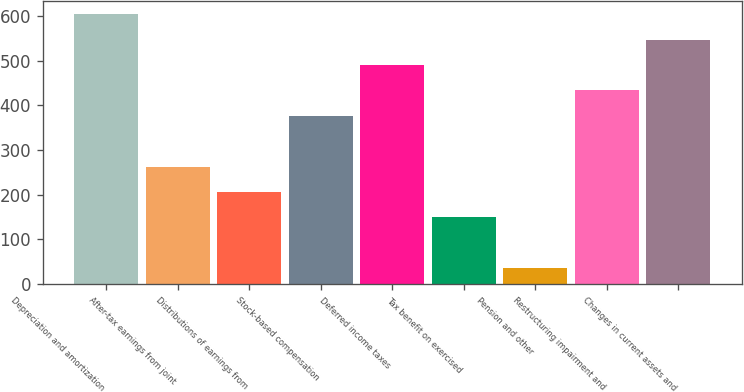Convert chart to OTSL. <chart><loc_0><loc_0><loc_500><loc_500><bar_chart><fcel>Depreciation and amortization<fcel>After-tax earnings from joint<fcel>Distributions of earnings from<fcel>Stock-based compensation<fcel>Deferred income taxes<fcel>Tax benefit on exercised<fcel>Pension and other<fcel>Restructuring impairment and<fcel>Changes in current assets and<nl><fcel>603.6<fcel>262.86<fcel>206.07<fcel>376.44<fcel>490.02<fcel>149.28<fcel>35.7<fcel>433.23<fcel>546.81<nl></chart> 